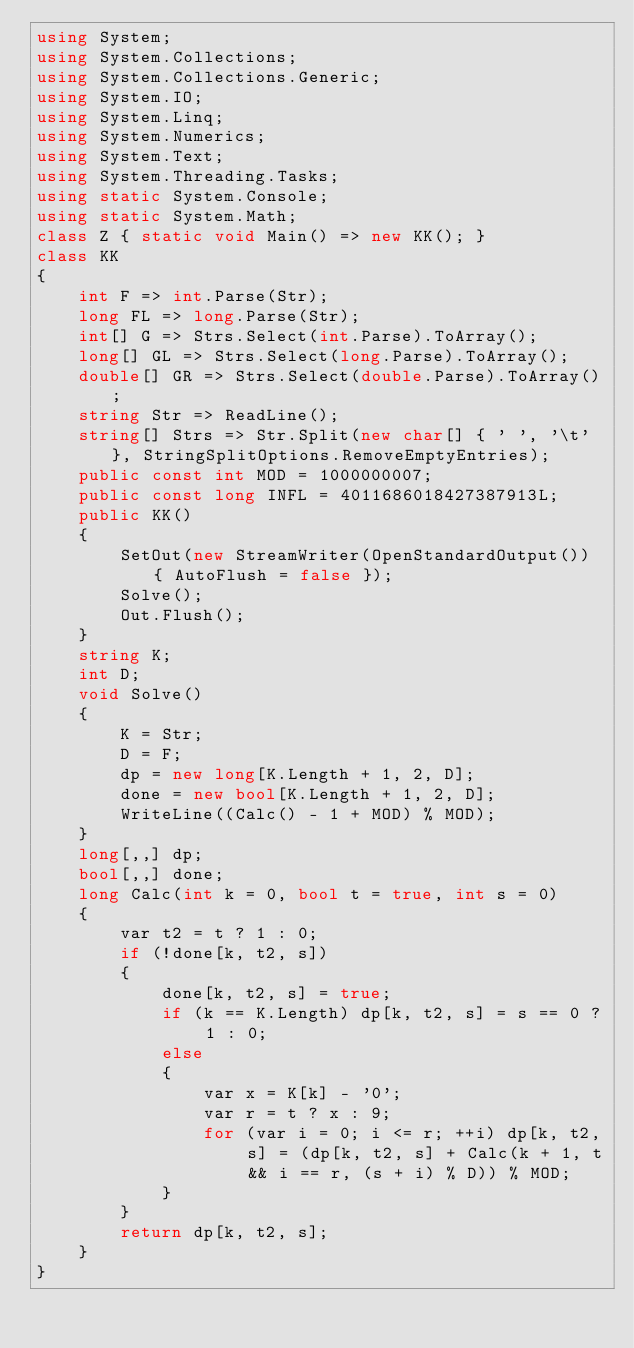Convert code to text. <code><loc_0><loc_0><loc_500><loc_500><_C#_>using System;
using System.Collections;
using System.Collections.Generic;
using System.IO;
using System.Linq;
using System.Numerics;
using System.Text;
using System.Threading.Tasks;
using static System.Console;
using static System.Math;
class Z { static void Main() => new KK(); }
class KK
{
	int F => int.Parse(Str);
	long FL => long.Parse(Str);
	int[] G => Strs.Select(int.Parse).ToArray();
	long[] GL => Strs.Select(long.Parse).ToArray();
	double[] GR => Strs.Select(double.Parse).ToArray();
	string Str => ReadLine();
	string[] Strs => Str.Split(new char[] { ' ', '\t' }, StringSplitOptions.RemoveEmptyEntries);
	public const int MOD = 1000000007;
	public const long INFL = 4011686018427387913L;
	public KK()
	{
		SetOut(new StreamWriter(OpenStandardOutput()) { AutoFlush = false });
		Solve();
		Out.Flush();
	}
	string K;
	int D;
	void Solve()
	{
		K = Str;
		D = F;
		dp = new long[K.Length + 1, 2, D];
		done = new bool[K.Length + 1, 2, D];
		WriteLine((Calc() - 1 + MOD) % MOD);
	}
	long[,,] dp;
	bool[,,] done;
	long Calc(int k = 0, bool t = true, int s = 0)
	{
		var t2 = t ? 1 : 0;
		if (!done[k, t2, s])
		{
			done[k, t2, s] = true;
			if (k == K.Length) dp[k, t2, s] = s == 0 ? 1 : 0;
			else
			{
				var x = K[k] - '0';
				var r = t ? x : 9;
				for (var i = 0; i <= r; ++i) dp[k, t2, s] = (dp[k, t2, s] + Calc(k + 1, t && i == r, (s + i) % D)) % MOD;
			}
		}
		return dp[k, t2, s];
	}
}
</code> 